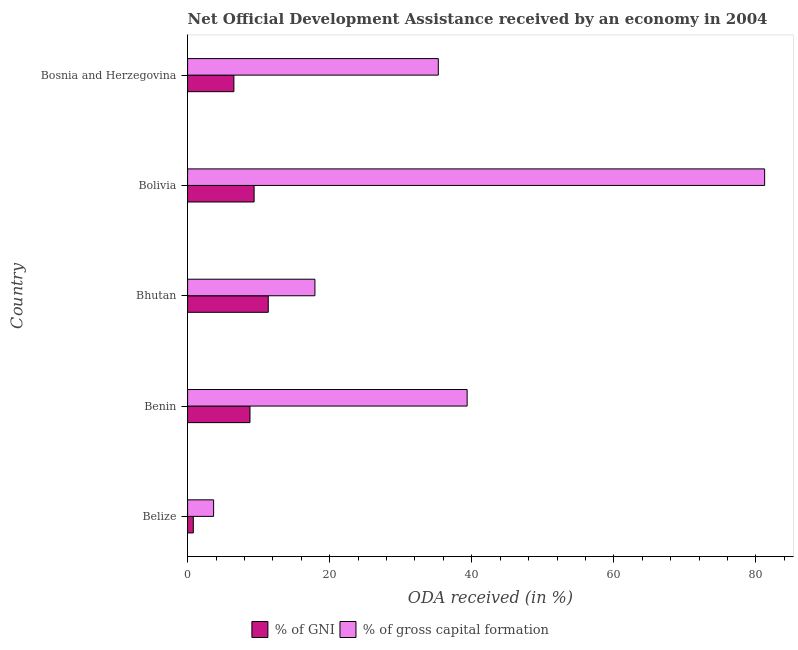How many different coloured bars are there?
Your answer should be compact. 2. Are the number of bars per tick equal to the number of legend labels?
Your answer should be compact. Yes. Are the number of bars on each tick of the Y-axis equal?
Offer a terse response. Yes. How many bars are there on the 2nd tick from the bottom?
Your answer should be very brief. 2. What is the label of the 5th group of bars from the top?
Make the answer very short. Belize. What is the oda received as percentage of gni in Belize?
Keep it short and to the point. 0.81. Across all countries, what is the maximum oda received as percentage of gross capital formation?
Provide a short and direct response. 81.23. Across all countries, what is the minimum oda received as percentage of gross capital formation?
Ensure brevity in your answer.  3.66. In which country was the oda received as percentage of gni maximum?
Keep it short and to the point. Bhutan. In which country was the oda received as percentage of gni minimum?
Offer a very short reply. Belize. What is the total oda received as percentage of gross capital formation in the graph?
Your response must be concise. 177.45. What is the difference between the oda received as percentage of gross capital formation in Belize and that in Bolivia?
Offer a very short reply. -77.56. What is the difference between the oda received as percentage of gross capital formation in Benin and the oda received as percentage of gni in Bosnia and Herzegovina?
Offer a very short reply. 32.83. What is the average oda received as percentage of gross capital formation per country?
Your answer should be compact. 35.49. What is the difference between the oda received as percentage of gni and oda received as percentage of gross capital formation in Bosnia and Herzegovina?
Give a very brief answer. -28.77. What is the ratio of the oda received as percentage of gni in Belize to that in Bosnia and Herzegovina?
Keep it short and to the point. 0.12. What is the difference between the highest and the second highest oda received as percentage of gni?
Your response must be concise. 1.99. What is the difference between the highest and the lowest oda received as percentage of gni?
Provide a short and direct response. 10.55. What does the 2nd bar from the top in Bosnia and Herzegovina represents?
Give a very brief answer. % of GNI. What does the 1st bar from the bottom in Belize represents?
Offer a terse response. % of GNI. What is the difference between two consecutive major ticks on the X-axis?
Offer a very short reply. 20. Are the values on the major ticks of X-axis written in scientific E-notation?
Ensure brevity in your answer.  No. What is the title of the graph?
Make the answer very short. Net Official Development Assistance received by an economy in 2004. Does "Unregistered firms" appear as one of the legend labels in the graph?
Your answer should be compact. No. What is the label or title of the X-axis?
Offer a terse response. ODA received (in %). What is the label or title of the Y-axis?
Ensure brevity in your answer.  Country. What is the ODA received (in %) of % of GNI in Belize?
Provide a short and direct response. 0.81. What is the ODA received (in %) in % of gross capital formation in Belize?
Ensure brevity in your answer.  3.66. What is the ODA received (in %) in % of GNI in Benin?
Offer a terse response. 8.78. What is the ODA received (in %) in % of gross capital formation in Benin?
Ensure brevity in your answer.  39.35. What is the ODA received (in %) of % of GNI in Bhutan?
Give a very brief answer. 11.35. What is the ODA received (in %) in % of gross capital formation in Bhutan?
Make the answer very short. 17.92. What is the ODA received (in %) in % of GNI in Bolivia?
Offer a terse response. 9.36. What is the ODA received (in %) of % of gross capital formation in Bolivia?
Your answer should be compact. 81.23. What is the ODA received (in %) of % of GNI in Bosnia and Herzegovina?
Keep it short and to the point. 6.52. What is the ODA received (in %) in % of gross capital formation in Bosnia and Herzegovina?
Offer a very short reply. 35.29. Across all countries, what is the maximum ODA received (in %) in % of GNI?
Keep it short and to the point. 11.35. Across all countries, what is the maximum ODA received (in %) of % of gross capital formation?
Provide a short and direct response. 81.23. Across all countries, what is the minimum ODA received (in %) of % of GNI?
Offer a very short reply. 0.81. Across all countries, what is the minimum ODA received (in %) of % of gross capital formation?
Make the answer very short. 3.66. What is the total ODA received (in %) in % of GNI in the graph?
Your answer should be very brief. 36.82. What is the total ODA received (in %) of % of gross capital formation in the graph?
Provide a short and direct response. 177.45. What is the difference between the ODA received (in %) of % of GNI in Belize and that in Benin?
Give a very brief answer. -7.98. What is the difference between the ODA received (in %) of % of gross capital formation in Belize and that in Benin?
Give a very brief answer. -35.68. What is the difference between the ODA received (in %) in % of GNI in Belize and that in Bhutan?
Offer a very short reply. -10.55. What is the difference between the ODA received (in %) in % of gross capital formation in Belize and that in Bhutan?
Provide a short and direct response. -14.26. What is the difference between the ODA received (in %) of % of GNI in Belize and that in Bolivia?
Ensure brevity in your answer.  -8.56. What is the difference between the ODA received (in %) of % of gross capital formation in Belize and that in Bolivia?
Provide a succinct answer. -77.56. What is the difference between the ODA received (in %) of % of GNI in Belize and that in Bosnia and Herzegovina?
Offer a very short reply. -5.71. What is the difference between the ODA received (in %) of % of gross capital formation in Belize and that in Bosnia and Herzegovina?
Ensure brevity in your answer.  -31.63. What is the difference between the ODA received (in %) in % of GNI in Benin and that in Bhutan?
Your answer should be very brief. -2.57. What is the difference between the ODA received (in %) of % of gross capital formation in Benin and that in Bhutan?
Ensure brevity in your answer.  21.43. What is the difference between the ODA received (in %) of % of GNI in Benin and that in Bolivia?
Offer a terse response. -0.58. What is the difference between the ODA received (in %) of % of gross capital formation in Benin and that in Bolivia?
Provide a short and direct response. -41.88. What is the difference between the ODA received (in %) of % of GNI in Benin and that in Bosnia and Herzegovina?
Your response must be concise. 2.26. What is the difference between the ODA received (in %) in % of gross capital formation in Benin and that in Bosnia and Herzegovina?
Keep it short and to the point. 4.06. What is the difference between the ODA received (in %) in % of GNI in Bhutan and that in Bolivia?
Provide a succinct answer. 1.99. What is the difference between the ODA received (in %) in % of gross capital formation in Bhutan and that in Bolivia?
Keep it short and to the point. -63.3. What is the difference between the ODA received (in %) in % of GNI in Bhutan and that in Bosnia and Herzegovina?
Provide a short and direct response. 4.84. What is the difference between the ODA received (in %) in % of gross capital formation in Bhutan and that in Bosnia and Herzegovina?
Make the answer very short. -17.37. What is the difference between the ODA received (in %) in % of GNI in Bolivia and that in Bosnia and Herzegovina?
Ensure brevity in your answer.  2.85. What is the difference between the ODA received (in %) in % of gross capital formation in Bolivia and that in Bosnia and Herzegovina?
Keep it short and to the point. 45.93. What is the difference between the ODA received (in %) of % of GNI in Belize and the ODA received (in %) of % of gross capital formation in Benin?
Ensure brevity in your answer.  -38.54. What is the difference between the ODA received (in %) of % of GNI in Belize and the ODA received (in %) of % of gross capital formation in Bhutan?
Your response must be concise. -17.12. What is the difference between the ODA received (in %) in % of GNI in Belize and the ODA received (in %) in % of gross capital formation in Bolivia?
Give a very brief answer. -80.42. What is the difference between the ODA received (in %) of % of GNI in Belize and the ODA received (in %) of % of gross capital formation in Bosnia and Herzegovina?
Offer a very short reply. -34.49. What is the difference between the ODA received (in %) of % of GNI in Benin and the ODA received (in %) of % of gross capital formation in Bhutan?
Ensure brevity in your answer.  -9.14. What is the difference between the ODA received (in %) in % of GNI in Benin and the ODA received (in %) in % of gross capital formation in Bolivia?
Offer a terse response. -72.44. What is the difference between the ODA received (in %) in % of GNI in Benin and the ODA received (in %) in % of gross capital formation in Bosnia and Herzegovina?
Offer a very short reply. -26.51. What is the difference between the ODA received (in %) of % of GNI in Bhutan and the ODA received (in %) of % of gross capital formation in Bolivia?
Provide a short and direct response. -69.87. What is the difference between the ODA received (in %) of % of GNI in Bhutan and the ODA received (in %) of % of gross capital formation in Bosnia and Herzegovina?
Ensure brevity in your answer.  -23.94. What is the difference between the ODA received (in %) of % of GNI in Bolivia and the ODA received (in %) of % of gross capital formation in Bosnia and Herzegovina?
Your answer should be compact. -25.93. What is the average ODA received (in %) of % of GNI per country?
Offer a terse response. 7.36. What is the average ODA received (in %) of % of gross capital formation per country?
Keep it short and to the point. 35.49. What is the difference between the ODA received (in %) of % of GNI and ODA received (in %) of % of gross capital formation in Belize?
Give a very brief answer. -2.86. What is the difference between the ODA received (in %) in % of GNI and ODA received (in %) in % of gross capital formation in Benin?
Provide a short and direct response. -30.57. What is the difference between the ODA received (in %) of % of GNI and ODA received (in %) of % of gross capital formation in Bhutan?
Your response must be concise. -6.57. What is the difference between the ODA received (in %) of % of GNI and ODA received (in %) of % of gross capital formation in Bolivia?
Your answer should be very brief. -71.86. What is the difference between the ODA received (in %) in % of GNI and ODA received (in %) in % of gross capital formation in Bosnia and Herzegovina?
Provide a short and direct response. -28.77. What is the ratio of the ODA received (in %) in % of GNI in Belize to that in Benin?
Your answer should be compact. 0.09. What is the ratio of the ODA received (in %) in % of gross capital formation in Belize to that in Benin?
Keep it short and to the point. 0.09. What is the ratio of the ODA received (in %) of % of GNI in Belize to that in Bhutan?
Give a very brief answer. 0.07. What is the ratio of the ODA received (in %) of % of gross capital formation in Belize to that in Bhutan?
Your response must be concise. 0.2. What is the ratio of the ODA received (in %) in % of GNI in Belize to that in Bolivia?
Give a very brief answer. 0.09. What is the ratio of the ODA received (in %) of % of gross capital formation in Belize to that in Bolivia?
Keep it short and to the point. 0.05. What is the ratio of the ODA received (in %) in % of GNI in Belize to that in Bosnia and Herzegovina?
Your answer should be compact. 0.12. What is the ratio of the ODA received (in %) in % of gross capital formation in Belize to that in Bosnia and Herzegovina?
Provide a succinct answer. 0.1. What is the ratio of the ODA received (in %) in % of GNI in Benin to that in Bhutan?
Make the answer very short. 0.77. What is the ratio of the ODA received (in %) of % of gross capital formation in Benin to that in Bhutan?
Your answer should be very brief. 2.2. What is the ratio of the ODA received (in %) in % of GNI in Benin to that in Bolivia?
Offer a terse response. 0.94. What is the ratio of the ODA received (in %) in % of gross capital formation in Benin to that in Bolivia?
Keep it short and to the point. 0.48. What is the ratio of the ODA received (in %) in % of GNI in Benin to that in Bosnia and Herzegovina?
Give a very brief answer. 1.35. What is the ratio of the ODA received (in %) of % of gross capital formation in Benin to that in Bosnia and Herzegovina?
Ensure brevity in your answer.  1.11. What is the ratio of the ODA received (in %) of % of GNI in Bhutan to that in Bolivia?
Give a very brief answer. 1.21. What is the ratio of the ODA received (in %) in % of gross capital formation in Bhutan to that in Bolivia?
Provide a short and direct response. 0.22. What is the ratio of the ODA received (in %) of % of GNI in Bhutan to that in Bosnia and Herzegovina?
Your answer should be very brief. 1.74. What is the ratio of the ODA received (in %) in % of gross capital formation in Bhutan to that in Bosnia and Herzegovina?
Make the answer very short. 0.51. What is the ratio of the ODA received (in %) of % of GNI in Bolivia to that in Bosnia and Herzegovina?
Offer a very short reply. 1.44. What is the ratio of the ODA received (in %) of % of gross capital formation in Bolivia to that in Bosnia and Herzegovina?
Make the answer very short. 2.3. What is the difference between the highest and the second highest ODA received (in %) of % of GNI?
Offer a very short reply. 1.99. What is the difference between the highest and the second highest ODA received (in %) in % of gross capital formation?
Provide a short and direct response. 41.88. What is the difference between the highest and the lowest ODA received (in %) in % of GNI?
Offer a very short reply. 10.55. What is the difference between the highest and the lowest ODA received (in %) in % of gross capital formation?
Ensure brevity in your answer.  77.56. 